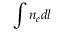<formula> <loc_0><loc_0><loc_500><loc_500>\int n _ { e } d l</formula> 